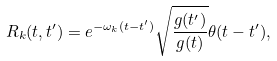<formula> <loc_0><loc_0><loc_500><loc_500>R _ { k } ( t , t ^ { \prime } ) = e ^ { - \omega _ { k } ( t - t ^ { \prime } ) } \sqrt { \frac { g ( t ^ { \prime } ) } { g ( t ) } } \theta ( t - t ^ { \prime } ) ,</formula> 